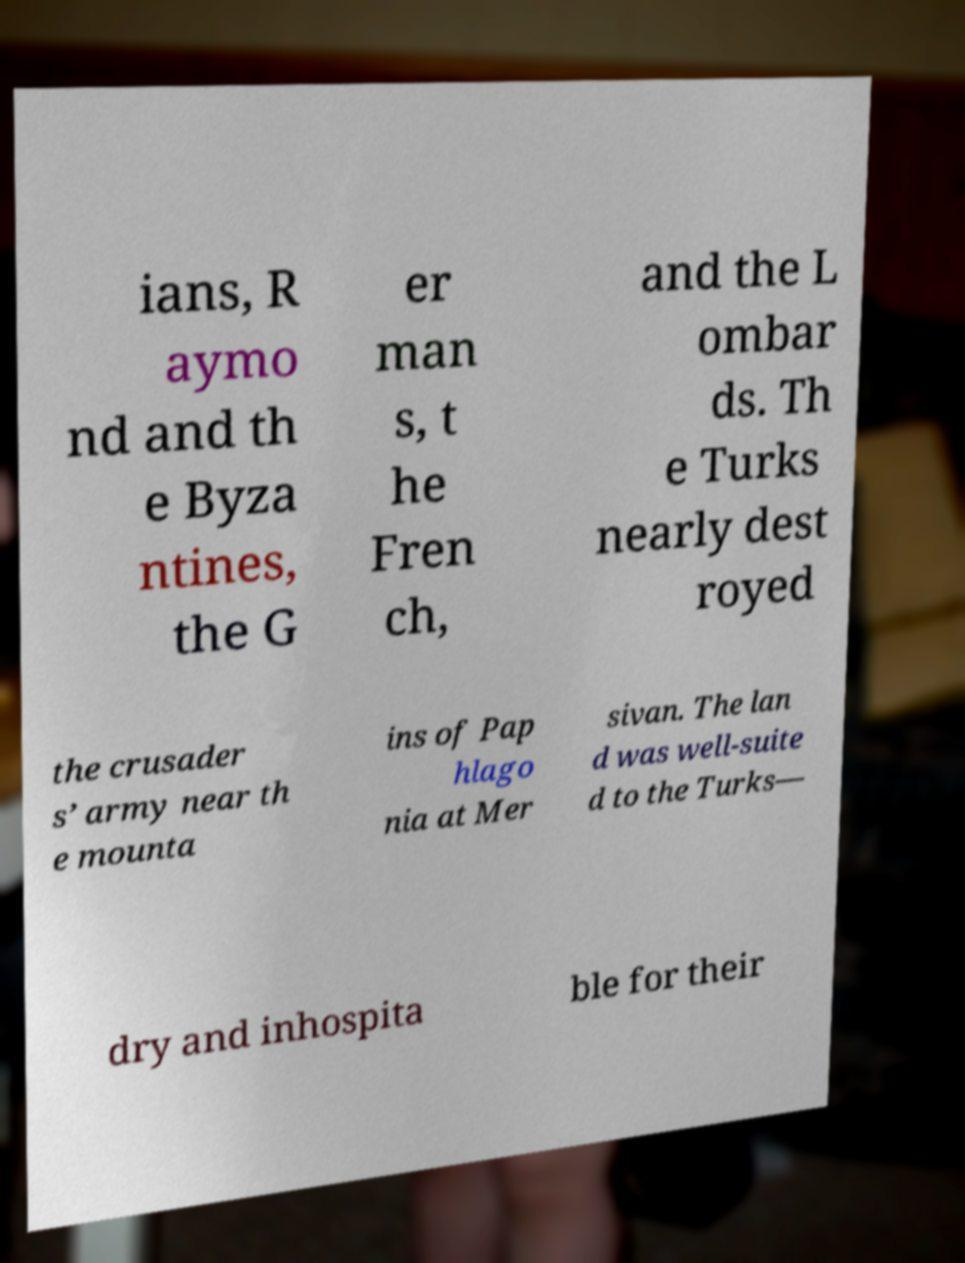Please identify and transcribe the text found in this image. ians, R aymo nd and th e Byza ntines, the G er man s, t he Fren ch, and the L ombar ds. Th e Turks nearly dest royed the crusader s’ army near th e mounta ins of Pap hlago nia at Mer sivan. The lan d was well-suite d to the Turks— dry and inhospita ble for their 